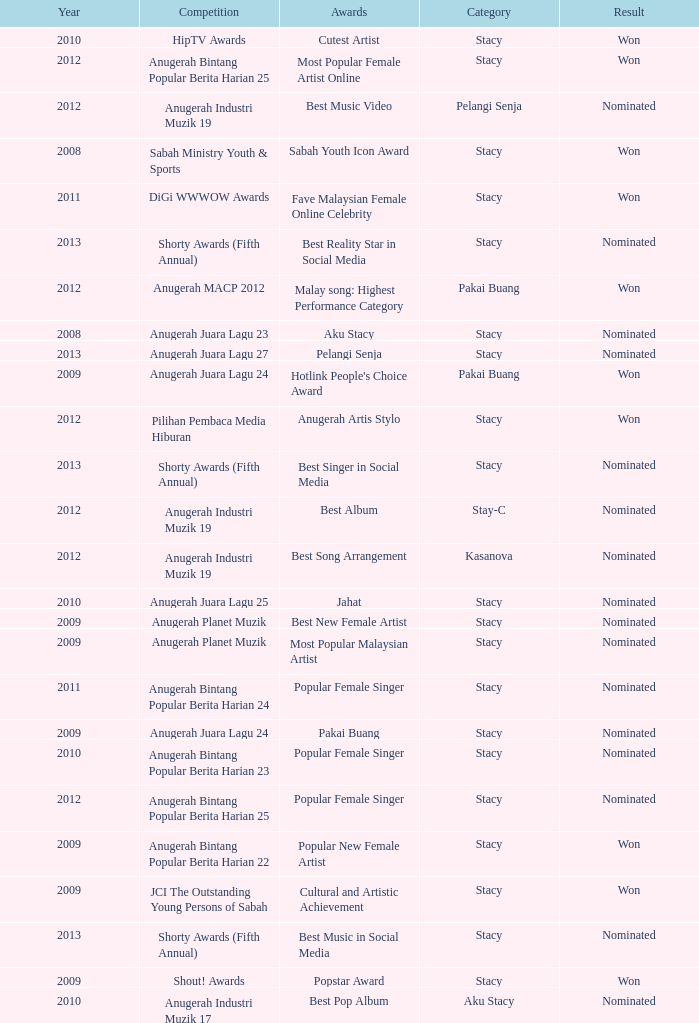I'm looking to parse the entire table for insights. Could you assist me with that? {'header': ['Year', 'Competition', 'Awards', 'Category', 'Result'], 'rows': [['2010', 'HipTV Awards', 'Cutest Artist', 'Stacy', 'Won'], ['2012', 'Anugerah Bintang Popular Berita Harian 25', 'Most Popular Female Artist Online', 'Stacy', 'Won'], ['2012', 'Anugerah Industri Muzik 19', 'Best Music Video', 'Pelangi Senja', 'Nominated'], ['2008', 'Sabah Ministry Youth & Sports', 'Sabah Youth Icon Award', 'Stacy', 'Won'], ['2011', 'DiGi WWWOW Awards', 'Fave Malaysian Female Online Celebrity', 'Stacy', 'Won'], ['2013', 'Shorty Awards (Fifth Annual)', 'Best Reality Star in Social Media', 'Stacy', 'Nominated'], ['2012', 'Anugerah MACP 2012', 'Malay song: Highest Performance Category', 'Pakai Buang', 'Won'], ['2008', 'Anugerah Juara Lagu 23', 'Aku Stacy', 'Stacy', 'Nominated'], ['2013', 'Anugerah Juara Lagu 27', 'Pelangi Senja', 'Stacy', 'Nominated'], ['2009', 'Anugerah Juara Lagu 24', "Hotlink People's Choice Award", 'Pakai Buang', 'Won'], ['2012', 'Pilihan Pembaca Media Hiburan', 'Anugerah Artis Stylo', 'Stacy', 'Won'], ['2013', 'Shorty Awards (Fifth Annual)', 'Best Singer in Social Media', 'Stacy', 'Nominated'], ['2012', 'Anugerah Industri Muzik 19', 'Best Album', 'Stay-C', 'Nominated'], ['2012', 'Anugerah Industri Muzik 19', 'Best Song Arrangement', 'Kasanova', 'Nominated'], ['2010', 'Anugerah Juara Lagu 25', 'Jahat', 'Stacy', 'Nominated'], ['2009', 'Anugerah Planet Muzik', 'Best New Female Artist', 'Stacy', 'Nominated'], ['2009', 'Anugerah Planet Muzik', 'Most Popular Malaysian Artist', 'Stacy', 'Nominated'], ['2011', 'Anugerah Bintang Popular Berita Harian 24', 'Popular Female Singer', 'Stacy', 'Nominated'], ['2009', 'Anugerah Juara Lagu 24', 'Pakai Buang', 'Stacy', 'Nominated'], ['2010', 'Anugerah Bintang Popular Berita Harian 23', 'Popular Female Singer', 'Stacy', 'Nominated'], ['2012', 'Anugerah Bintang Popular Berita Harian 25', 'Popular Female Singer', 'Stacy', 'Nominated'], ['2009', 'Anugerah Bintang Popular Berita Harian 22', 'Popular New Female Artist', 'Stacy', 'Won'], ['2009', 'JCI The Outstanding Young Persons of Sabah', 'Cultural and Artistic Achievement', 'Stacy', 'Won'], ['2013', 'Shorty Awards (Fifth Annual)', 'Best Music in Social Media', 'Stacy', 'Nominated'], ['2009', 'Shout! Awards', 'Popstar Award', 'Stacy', 'Won'], ['2010', 'Anugerah Industri Muzik 17', 'Best Pop Album', 'Aku Stacy', 'Nominated']]} What year has Stacy as the category and award of Best Reality Star in Social Media? 2013.0. 